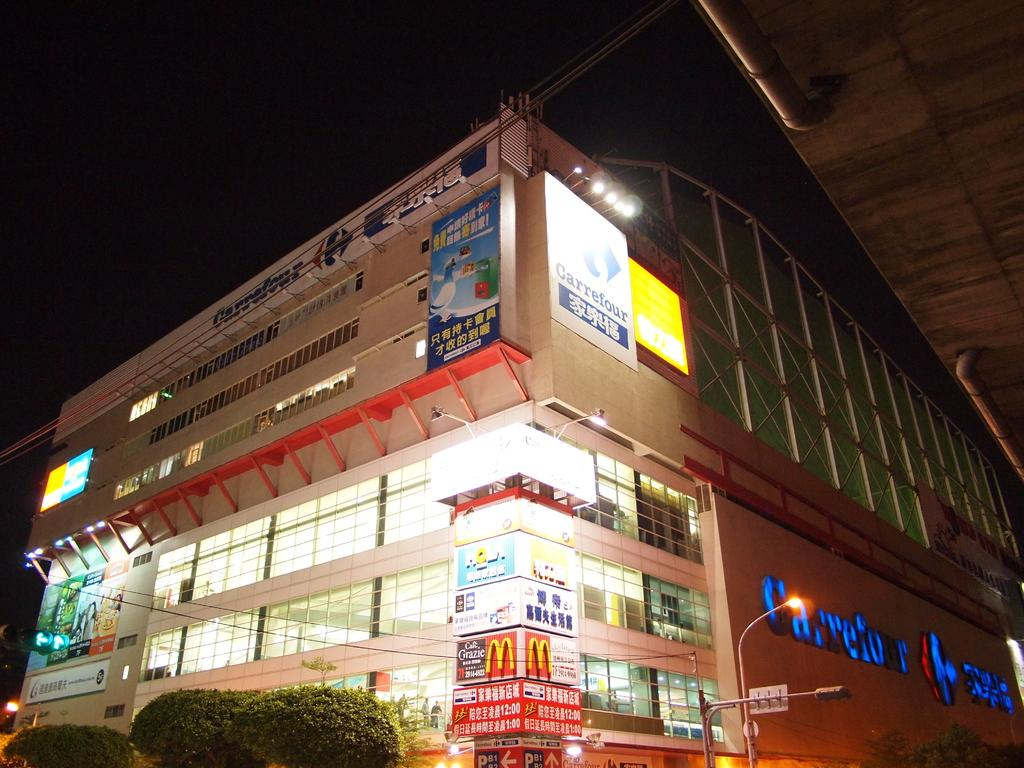What type of structure is in the image? There is a building in the image. What can be seen at the top of the building? The top of the building has a dark view. What type of vegetation is at the bottom of the image? There are trees at the bottom of the image. What type of lighting is present at the bottom of the image? Street light poles are visible at the bottom of the image. What type of prose is being recited by the trees in the image? There is no indication in the image that the trees are reciting any prose. 